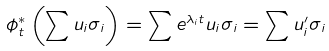Convert formula to latex. <formula><loc_0><loc_0><loc_500><loc_500>\phi _ { t } ^ { * } \left ( \sum u _ { i } \sigma _ { i } \right ) = \sum e ^ { \lambda _ { i } t } u _ { i } \sigma _ { i } = \sum u _ { i } ^ { \prime } \sigma _ { i }</formula> 